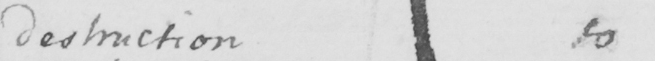What does this handwritten line say? destruction to 